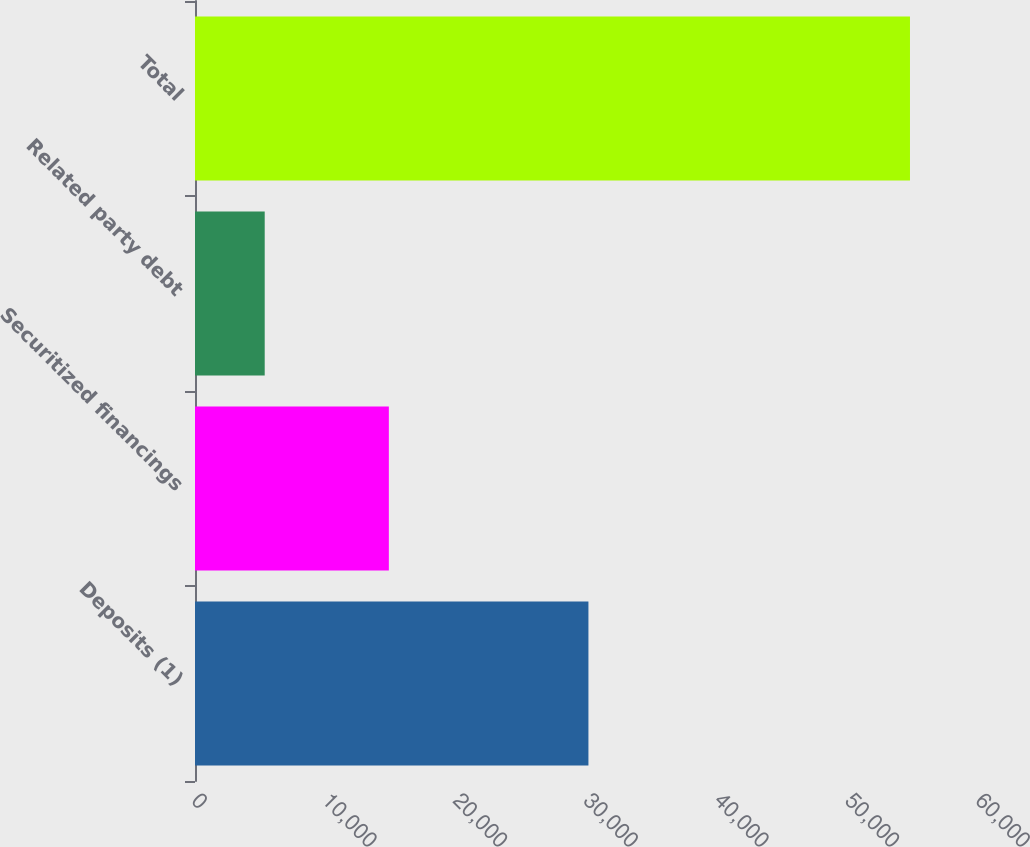<chart> <loc_0><loc_0><loc_500><loc_500><bar_chart><fcel>Deposits (1)<fcel>Securitized financings<fcel>Related party debt<fcel>Total<nl><fcel>30110<fcel>14835<fcel>5335<fcel>54718<nl></chart> 